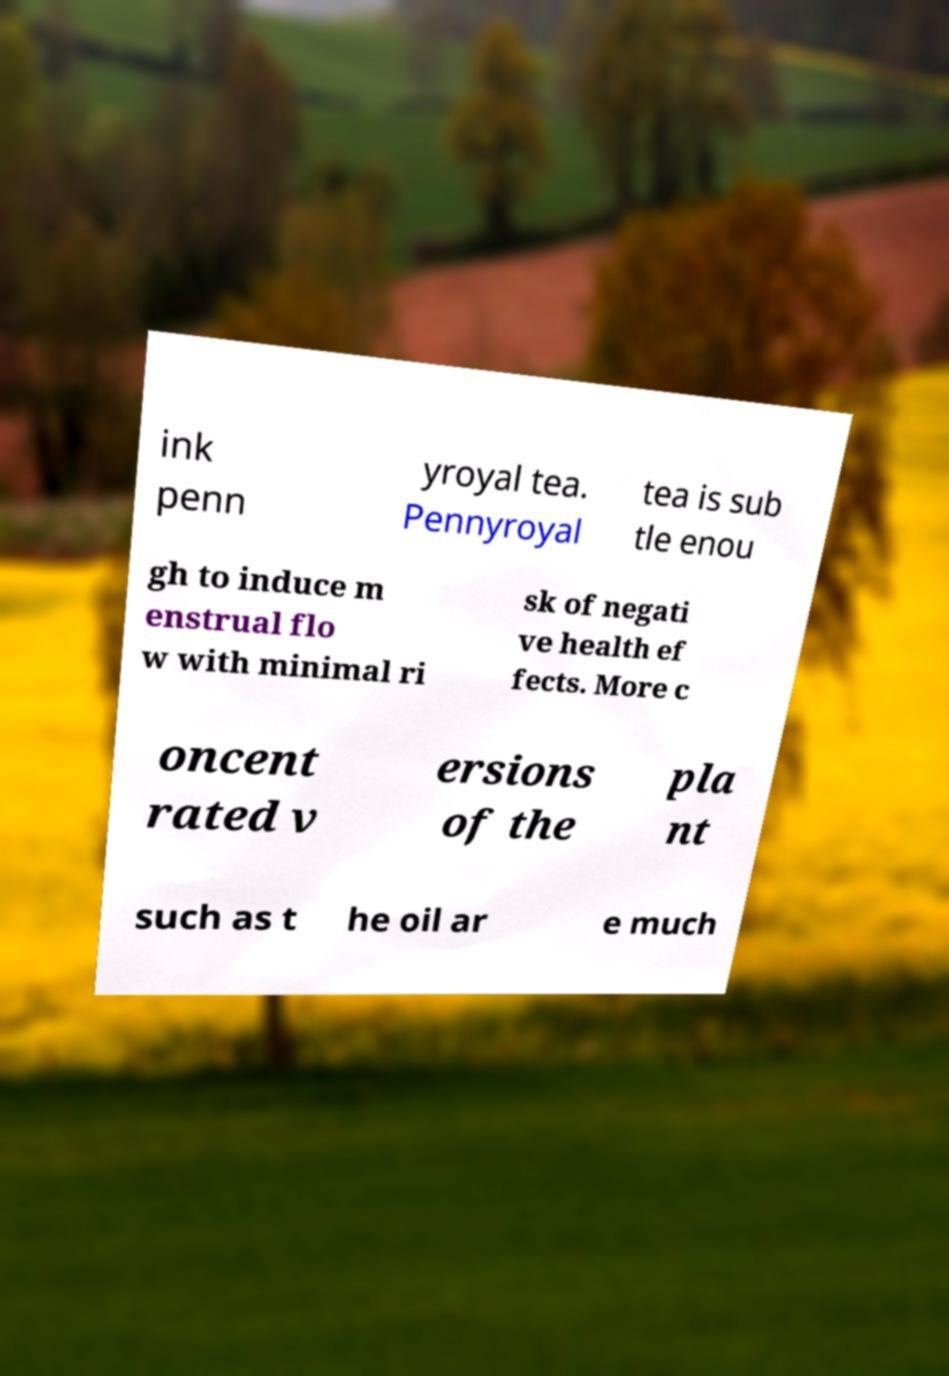What messages or text are displayed in this image? I need them in a readable, typed format. ink penn yroyal tea. Pennyroyal tea is sub tle enou gh to induce m enstrual flo w with minimal ri sk of negati ve health ef fects. More c oncent rated v ersions of the pla nt such as t he oil ar e much 